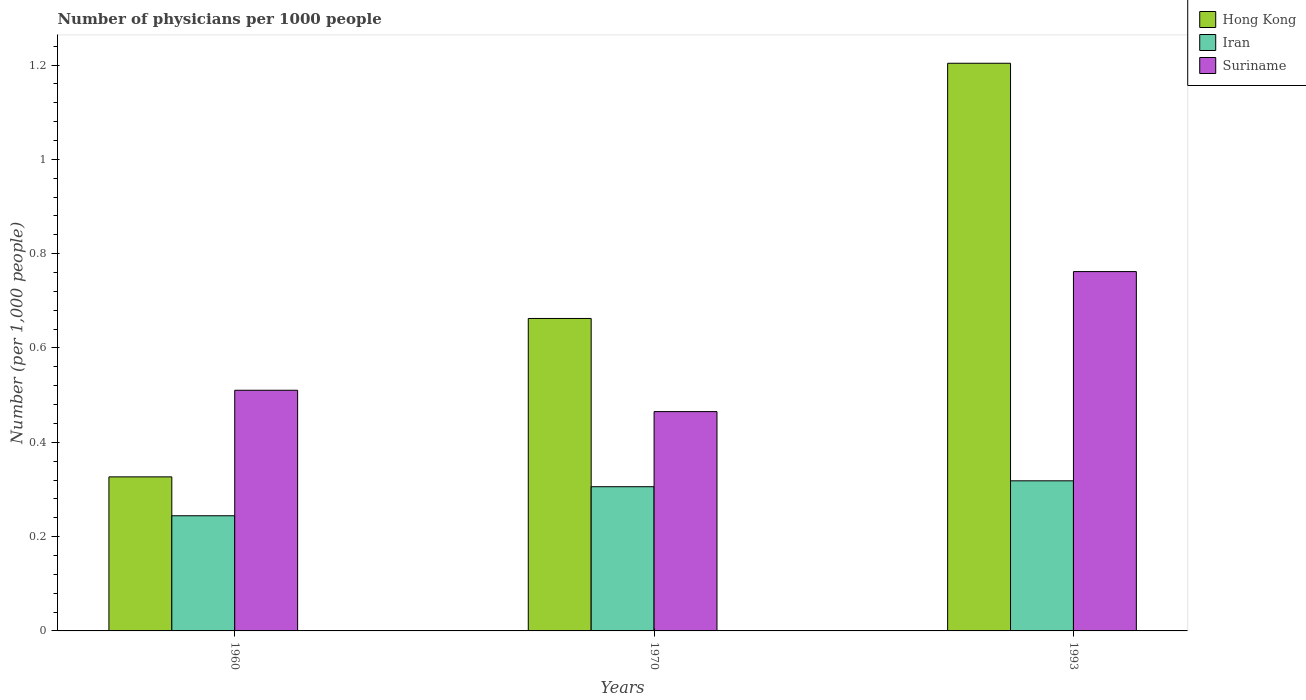How many bars are there on the 2nd tick from the left?
Provide a short and direct response. 3. How many bars are there on the 2nd tick from the right?
Offer a very short reply. 3. What is the number of physicians in Hong Kong in 1970?
Offer a terse response. 0.66. Across all years, what is the maximum number of physicians in Hong Kong?
Provide a succinct answer. 1.2. Across all years, what is the minimum number of physicians in Suriname?
Your response must be concise. 0.47. In which year was the number of physicians in Iran maximum?
Provide a short and direct response. 1993. What is the total number of physicians in Iran in the graph?
Give a very brief answer. 0.87. What is the difference between the number of physicians in Iran in 1970 and that in 1993?
Your answer should be compact. -0.01. What is the difference between the number of physicians in Suriname in 1993 and the number of physicians in Iran in 1970?
Provide a succinct answer. 0.46. What is the average number of physicians in Iran per year?
Make the answer very short. 0.29. In the year 1993, what is the difference between the number of physicians in Hong Kong and number of physicians in Suriname?
Offer a terse response. 0.44. In how many years, is the number of physicians in Suriname greater than 0.88?
Your answer should be very brief. 0. What is the ratio of the number of physicians in Suriname in 1960 to that in 1993?
Make the answer very short. 0.67. Is the number of physicians in Hong Kong in 1960 less than that in 1970?
Ensure brevity in your answer.  Yes. Is the difference between the number of physicians in Hong Kong in 1970 and 1993 greater than the difference between the number of physicians in Suriname in 1970 and 1993?
Your response must be concise. No. What is the difference between the highest and the second highest number of physicians in Iran?
Your answer should be very brief. 0.01. What is the difference between the highest and the lowest number of physicians in Iran?
Ensure brevity in your answer.  0.07. In how many years, is the number of physicians in Suriname greater than the average number of physicians in Suriname taken over all years?
Offer a very short reply. 1. What does the 3rd bar from the left in 1993 represents?
Ensure brevity in your answer.  Suriname. What does the 1st bar from the right in 1970 represents?
Your response must be concise. Suriname. Is it the case that in every year, the sum of the number of physicians in Suriname and number of physicians in Hong Kong is greater than the number of physicians in Iran?
Provide a short and direct response. Yes. Are all the bars in the graph horizontal?
Provide a succinct answer. No. What is the difference between two consecutive major ticks on the Y-axis?
Provide a short and direct response. 0.2. Does the graph contain any zero values?
Provide a succinct answer. No. Does the graph contain grids?
Provide a short and direct response. No. Where does the legend appear in the graph?
Ensure brevity in your answer.  Top right. What is the title of the graph?
Offer a terse response. Number of physicians per 1000 people. What is the label or title of the Y-axis?
Give a very brief answer. Number (per 1,0 people). What is the Number (per 1,000 people) in Hong Kong in 1960?
Your answer should be compact. 0.33. What is the Number (per 1,000 people) in Iran in 1960?
Offer a very short reply. 0.24. What is the Number (per 1,000 people) in Suriname in 1960?
Give a very brief answer. 0.51. What is the Number (per 1,000 people) of Hong Kong in 1970?
Make the answer very short. 0.66. What is the Number (per 1,000 people) of Iran in 1970?
Make the answer very short. 0.31. What is the Number (per 1,000 people) of Suriname in 1970?
Your response must be concise. 0.47. What is the Number (per 1,000 people) in Hong Kong in 1993?
Your answer should be very brief. 1.2. What is the Number (per 1,000 people) in Iran in 1993?
Ensure brevity in your answer.  0.32. What is the Number (per 1,000 people) of Suriname in 1993?
Provide a succinct answer. 0.76. Across all years, what is the maximum Number (per 1,000 people) of Hong Kong?
Make the answer very short. 1.2. Across all years, what is the maximum Number (per 1,000 people) of Iran?
Your answer should be compact. 0.32. Across all years, what is the maximum Number (per 1,000 people) of Suriname?
Ensure brevity in your answer.  0.76. Across all years, what is the minimum Number (per 1,000 people) of Hong Kong?
Give a very brief answer. 0.33. Across all years, what is the minimum Number (per 1,000 people) of Iran?
Keep it short and to the point. 0.24. Across all years, what is the minimum Number (per 1,000 people) of Suriname?
Offer a very short reply. 0.47. What is the total Number (per 1,000 people) of Hong Kong in the graph?
Give a very brief answer. 2.19. What is the total Number (per 1,000 people) in Iran in the graph?
Offer a very short reply. 0.87. What is the total Number (per 1,000 people) of Suriname in the graph?
Provide a succinct answer. 1.74. What is the difference between the Number (per 1,000 people) of Hong Kong in 1960 and that in 1970?
Provide a succinct answer. -0.34. What is the difference between the Number (per 1,000 people) of Iran in 1960 and that in 1970?
Provide a short and direct response. -0.06. What is the difference between the Number (per 1,000 people) in Suriname in 1960 and that in 1970?
Give a very brief answer. 0.05. What is the difference between the Number (per 1,000 people) in Hong Kong in 1960 and that in 1993?
Your answer should be compact. -0.88. What is the difference between the Number (per 1,000 people) of Iran in 1960 and that in 1993?
Ensure brevity in your answer.  -0.07. What is the difference between the Number (per 1,000 people) in Suriname in 1960 and that in 1993?
Make the answer very short. -0.25. What is the difference between the Number (per 1,000 people) of Hong Kong in 1970 and that in 1993?
Your response must be concise. -0.54. What is the difference between the Number (per 1,000 people) in Iran in 1970 and that in 1993?
Provide a succinct answer. -0.01. What is the difference between the Number (per 1,000 people) in Suriname in 1970 and that in 1993?
Make the answer very short. -0.3. What is the difference between the Number (per 1,000 people) of Hong Kong in 1960 and the Number (per 1,000 people) of Iran in 1970?
Your response must be concise. 0.02. What is the difference between the Number (per 1,000 people) in Hong Kong in 1960 and the Number (per 1,000 people) in Suriname in 1970?
Your answer should be very brief. -0.14. What is the difference between the Number (per 1,000 people) of Iran in 1960 and the Number (per 1,000 people) of Suriname in 1970?
Keep it short and to the point. -0.22. What is the difference between the Number (per 1,000 people) of Hong Kong in 1960 and the Number (per 1,000 people) of Iran in 1993?
Offer a very short reply. 0.01. What is the difference between the Number (per 1,000 people) of Hong Kong in 1960 and the Number (per 1,000 people) of Suriname in 1993?
Your response must be concise. -0.44. What is the difference between the Number (per 1,000 people) of Iran in 1960 and the Number (per 1,000 people) of Suriname in 1993?
Your answer should be compact. -0.52. What is the difference between the Number (per 1,000 people) in Hong Kong in 1970 and the Number (per 1,000 people) in Iran in 1993?
Keep it short and to the point. 0.34. What is the difference between the Number (per 1,000 people) of Hong Kong in 1970 and the Number (per 1,000 people) of Suriname in 1993?
Provide a succinct answer. -0.1. What is the difference between the Number (per 1,000 people) of Iran in 1970 and the Number (per 1,000 people) of Suriname in 1993?
Your answer should be compact. -0.46. What is the average Number (per 1,000 people) in Hong Kong per year?
Keep it short and to the point. 0.73. What is the average Number (per 1,000 people) of Iran per year?
Ensure brevity in your answer.  0.29. What is the average Number (per 1,000 people) of Suriname per year?
Provide a short and direct response. 0.58. In the year 1960, what is the difference between the Number (per 1,000 people) of Hong Kong and Number (per 1,000 people) of Iran?
Offer a terse response. 0.08. In the year 1960, what is the difference between the Number (per 1,000 people) of Hong Kong and Number (per 1,000 people) of Suriname?
Your response must be concise. -0.18. In the year 1960, what is the difference between the Number (per 1,000 people) of Iran and Number (per 1,000 people) of Suriname?
Offer a very short reply. -0.27. In the year 1970, what is the difference between the Number (per 1,000 people) in Hong Kong and Number (per 1,000 people) in Iran?
Your answer should be very brief. 0.36. In the year 1970, what is the difference between the Number (per 1,000 people) of Hong Kong and Number (per 1,000 people) of Suriname?
Your answer should be very brief. 0.2. In the year 1970, what is the difference between the Number (per 1,000 people) in Iran and Number (per 1,000 people) in Suriname?
Your answer should be very brief. -0.16. In the year 1993, what is the difference between the Number (per 1,000 people) of Hong Kong and Number (per 1,000 people) of Iran?
Provide a short and direct response. 0.89. In the year 1993, what is the difference between the Number (per 1,000 people) in Hong Kong and Number (per 1,000 people) in Suriname?
Your answer should be compact. 0.44. In the year 1993, what is the difference between the Number (per 1,000 people) of Iran and Number (per 1,000 people) of Suriname?
Provide a short and direct response. -0.44. What is the ratio of the Number (per 1,000 people) of Hong Kong in 1960 to that in 1970?
Give a very brief answer. 0.49. What is the ratio of the Number (per 1,000 people) in Iran in 1960 to that in 1970?
Your answer should be compact. 0.8. What is the ratio of the Number (per 1,000 people) in Suriname in 1960 to that in 1970?
Keep it short and to the point. 1.1. What is the ratio of the Number (per 1,000 people) in Hong Kong in 1960 to that in 1993?
Give a very brief answer. 0.27. What is the ratio of the Number (per 1,000 people) of Iran in 1960 to that in 1993?
Give a very brief answer. 0.77. What is the ratio of the Number (per 1,000 people) of Suriname in 1960 to that in 1993?
Ensure brevity in your answer.  0.67. What is the ratio of the Number (per 1,000 people) of Hong Kong in 1970 to that in 1993?
Give a very brief answer. 0.55. What is the ratio of the Number (per 1,000 people) in Iran in 1970 to that in 1993?
Provide a succinct answer. 0.96. What is the ratio of the Number (per 1,000 people) in Suriname in 1970 to that in 1993?
Offer a terse response. 0.61. What is the difference between the highest and the second highest Number (per 1,000 people) of Hong Kong?
Offer a very short reply. 0.54. What is the difference between the highest and the second highest Number (per 1,000 people) in Iran?
Your answer should be very brief. 0.01. What is the difference between the highest and the second highest Number (per 1,000 people) of Suriname?
Offer a terse response. 0.25. What is the difference between the highest and the lowest Number (per 1,000 people) in Hong Kong?
Your answer should be compact. 0.88. What is the difference between the highest and the lowest Number (per 1,000 people) of Iran?
Offer a very short reply. 0.07. What is the difference between the highest and the lowest Number (per 1,000 people) of Suriname?
Provide a short and direct response. 0.3. 